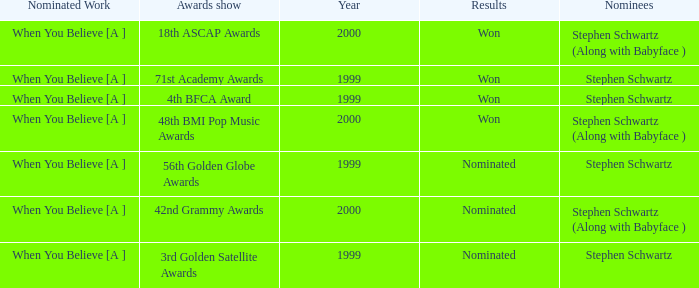What was the results of the 71st Academy Awards show? Won. 